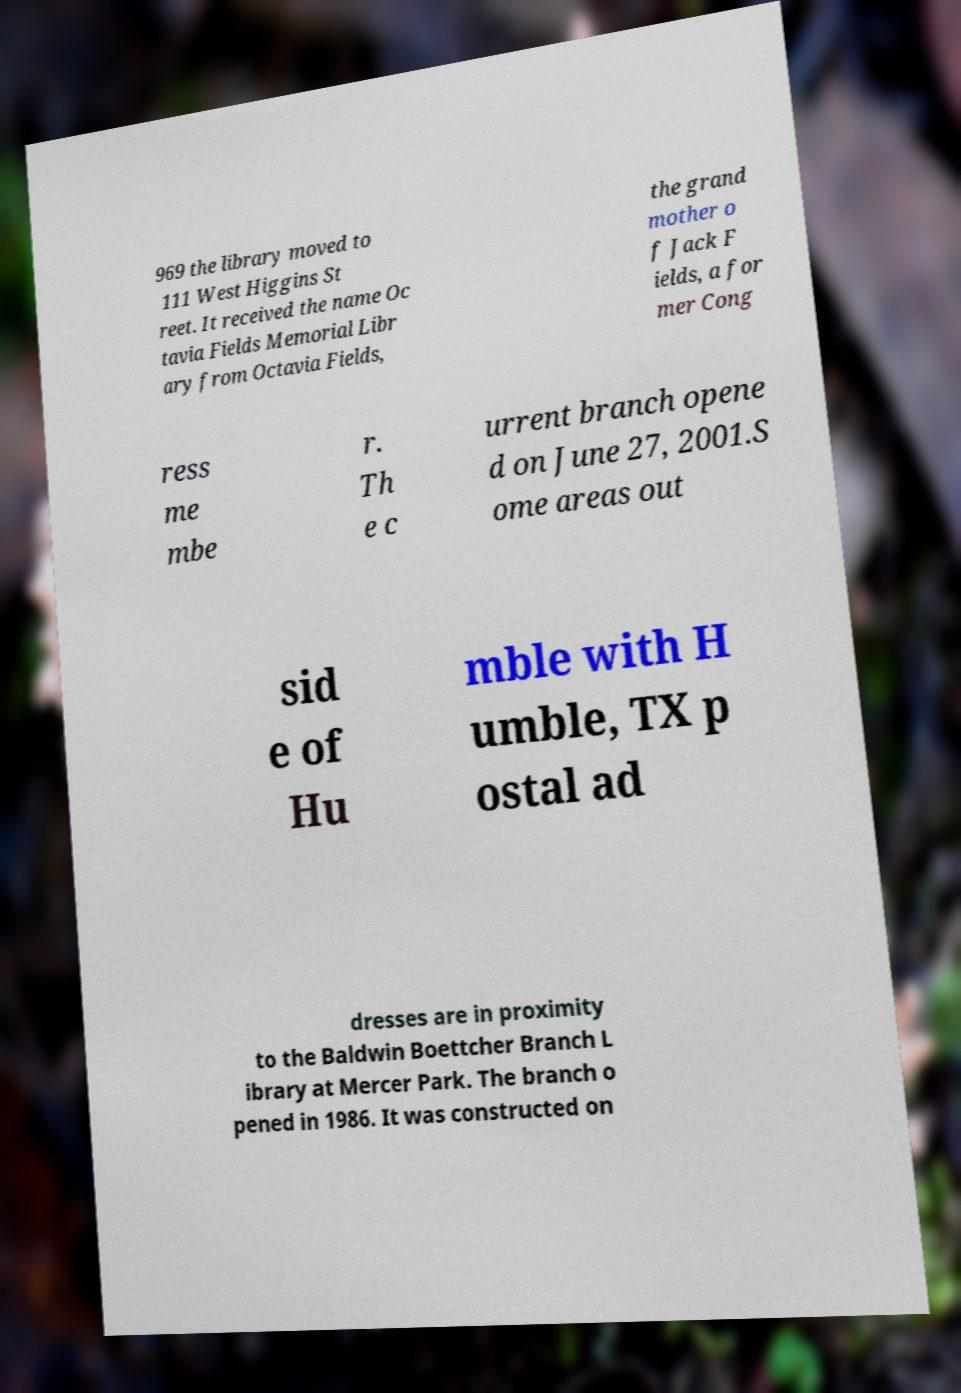Can you read and provide the text displayed in the image?This photo seems to have some interesting text. Can you extract and type it out for me? 969 the library moved to 111 West Higgins St reet. It received the name Oc tavia Fields Memorial Libr ary from Octavia Fields, the grand mother o f Jack F ields, a for mer Cong ress me mbe r. Th e c urrent branch opene d on June 27, 2001.S ome areas out sid e of Hu mble with H umble, TX p ostal ad dresses are in proximity to the Baldwin Boettcher Branch L ibrary at Mercer Park. The branch o pened in 1986. It was constructed on 